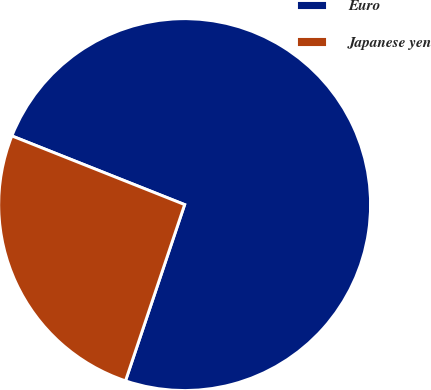Convert chart. <chart><loc_0><loc_0><loc_500><loc_500><pie_chart><fcel>Euro<fcel>Japanese yen<nl><fcel>74.13%<fcel>25.87%<nl></chart> 